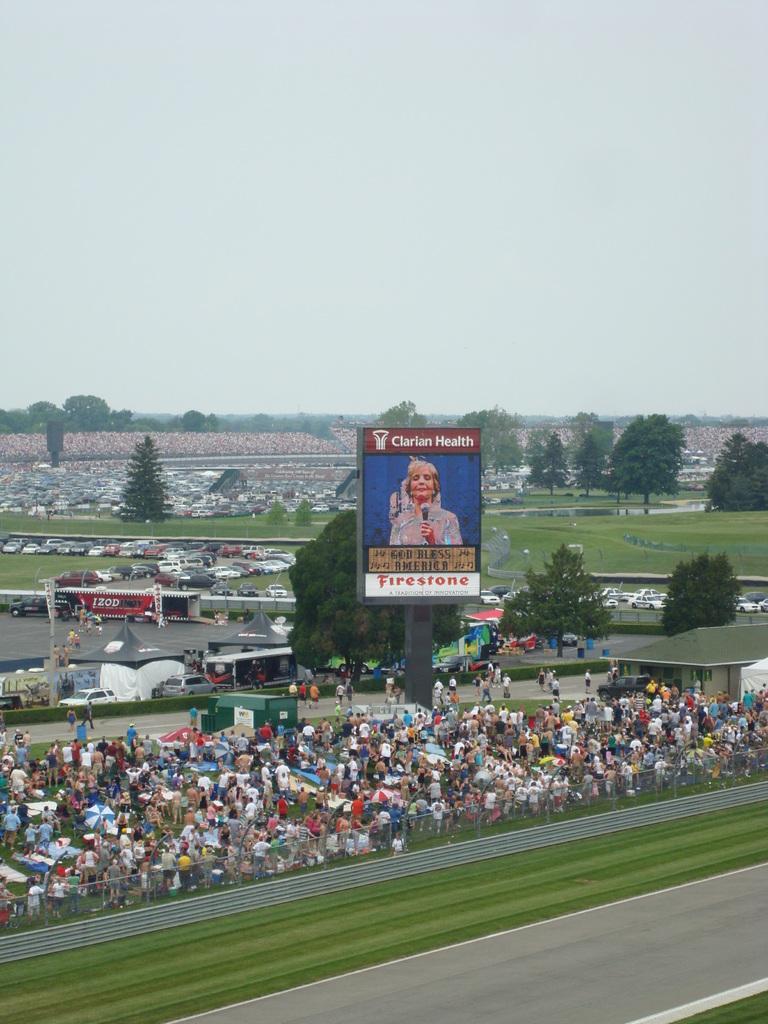Please provide a concise description of this image. In this image we can see a few people are standing, there is a big hoarding with a person image and text written on it, there are some vehicles, trees and houses, in the background we can see the sky. 